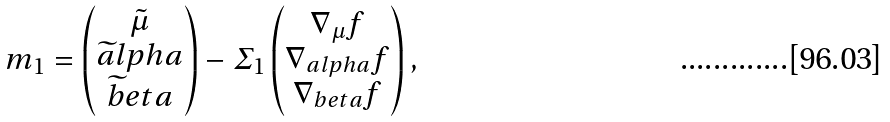Convert formula to latex. <formula><loc_0><loc_0><loc_500><loc_500>m _ { 1 } = \begin{pmatrix} \tilde { \mu } \\ \widetilde { a } l p h a \\ \widetilde { b } e t a \end{pmatrix} - \varSigma _ { 1 } \begin{pmatrix} \nabla _ { \mu } f \\ \nabla _ { a l p h a } f \\ \nabla _ { b e t a } f \end{pmatrix} ,</formula> 